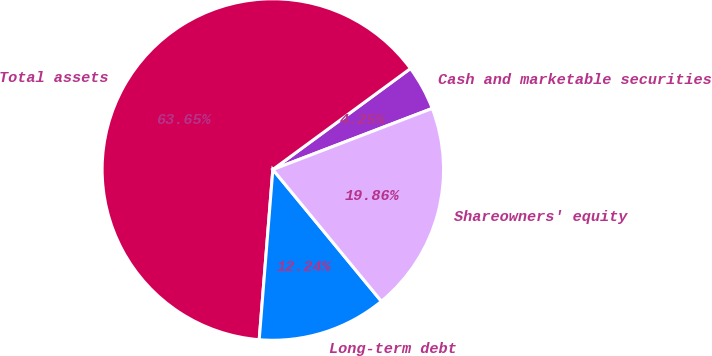Convert chart. <chart><loc_0><loc_0><loc_500><loc_500><pie_chart><fcel>Cash and marketable securities<fcel>Total assets<fcel>Long-term debt<fcel>Shareowners' equity<nl><fcel>4.25%<fcel>63.65%<fcel>12.24%<fcel>19.86%<nl></chart> 